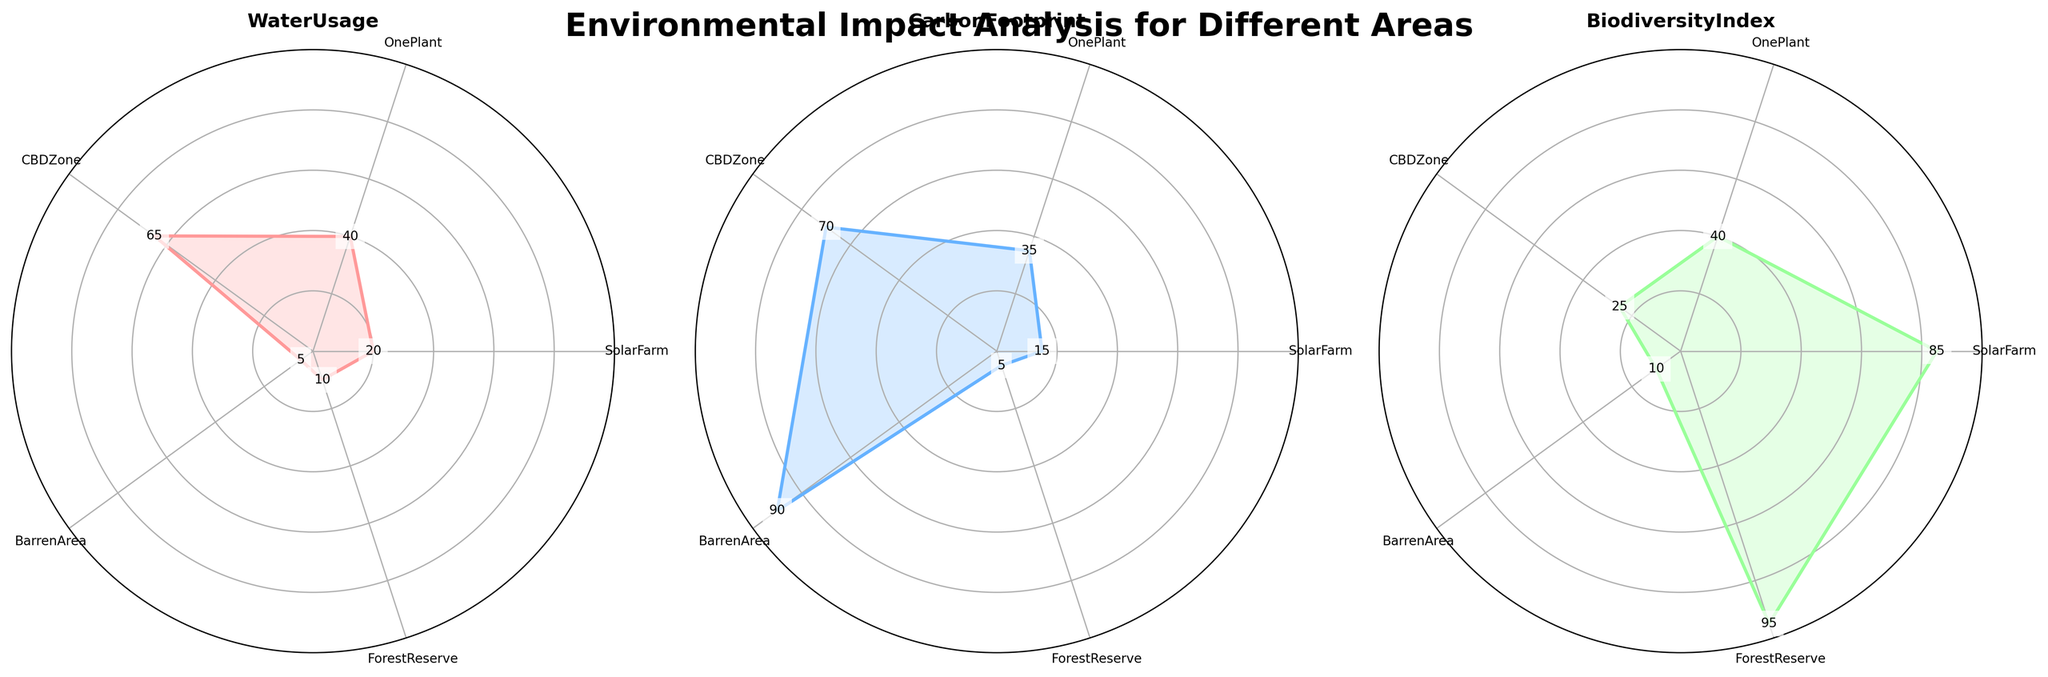What is the title of the figure? The title can be found at the top of the figure and it explains the overall purpose of the graphical representation.
Answer: Environmental Impact Analysis for Different Areas Which area has the highest Biodiversity Index? To determine this, look for the area with the highest value on the Biodiversity Index axis.
Answer: Forest Reserve What is the Carbon Footprint value for the BarrenArea? Locate the Carbon Footprint value on the plot corresponding to the BarrenArea sector.
Answer: 90 How does the Water Usage in SolarFarm compare to that in OnePlant? Compare the Water Usage values for SolarFarm and OnePlant. SolarFarm has 20 while OnePlant has 40.
Answer: SolarFarm has lower Water Usage than OnePlant Which area has the lowest Water Usage? Identify the smallest value on the Water Usage axis across all areas.
Answer: BarrenArea What is the sum of Water Usage and Carbon Footprint for the CBDZone? Add the values of Water Usage (65) and Carbon Footprint (70) for the CBDZone. 65 + 70 = 135.
Answer: 135 Compare the Biodiversity Index of CBDZone and SolarFarm. Look at the Biodiversity Index values for CBDZone and SolarFarm. CBDZone has 25 while SolarFarm has 85.
Answer: SolarFarm has a higher Biodiversity Index than CBDZone What are the color codes representing each area? Identify the colors corresponding to each area by looking at the plot.
Answer: SolarFarm: Red, OnePlant: Blue, CBDZone: Green, BarrenArea: Orange, ForestReserve: Pink Which area is more balanced with respect to all three metrics (least spikes in the plot)? Look for the plot with the most even distribution of values across the three axes.
Answer: OnePlant or ForestReserve Which two metrics have the smallest difference for ForestReserve? Calculate the absolute difference between each pair of metrics for ForestReserve (WaterUsage 10, CarbonFootprint 5, BiodiversityIndex 95) and find the pair with the smallest difference.
Answer: WaterUsage and CarbonFootprint 